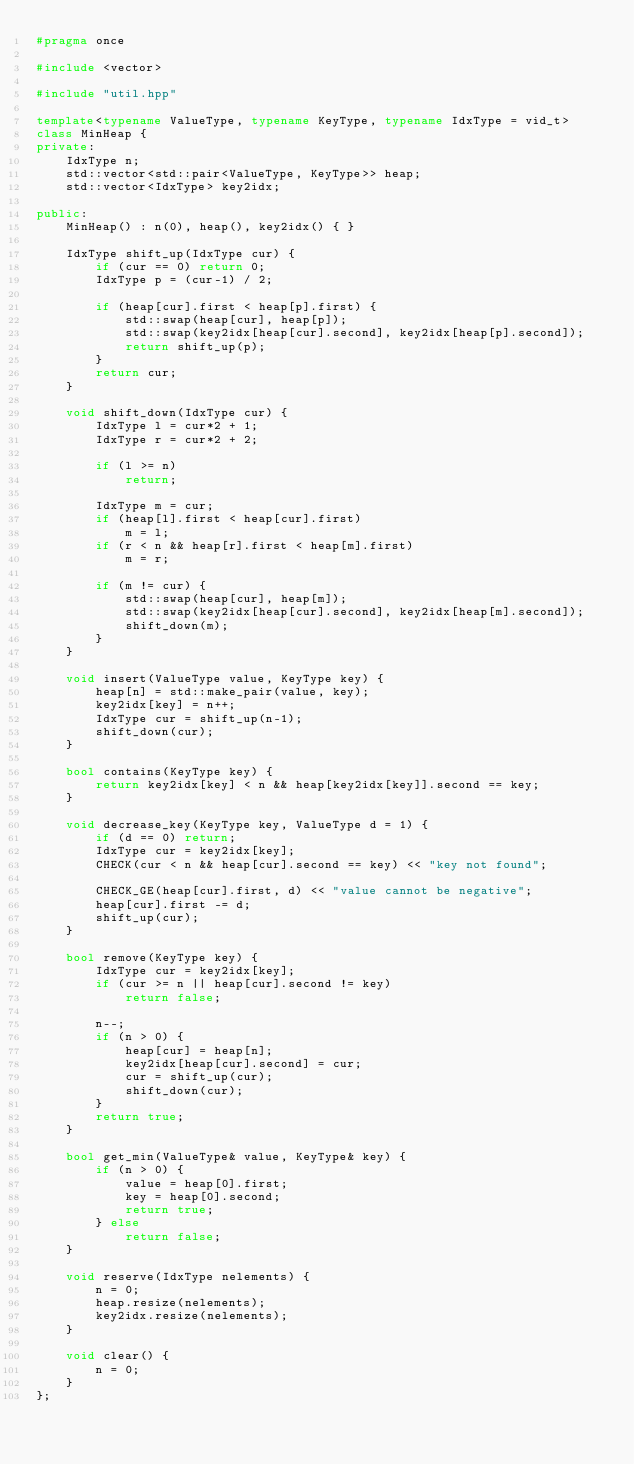<code> <loc_0><loc_0><loc_500><loc_500><_C++_>#pragma once

#include <vector>

#include "util.hpp"

template<typename ValueType, typename KeyType, typename IdxType = vid_t>
class MinHeap {
private:
    IdxType n;
    std::vector<std::pair<ValueType, KeyType>> heap;
    std::vector<IdxType> key2idx;

public:
    MinHeap() : n(0), heap(), key2idx() { }

    IdxType shift_up(IdxType cur) {
        if (cur == 0) return 0;
        IdxType p = (cur-1) / 2;

        if (heap[cur].first < heap[p].first) {
            std::swap(heap[cur], heap[p]);
            std::swap(key2idx[heap[cur].second], key2idx[heap[p].second]);
            return shift_up(p);
        }
        return cur;
    }

    void shift_down(IdxType cur) {
        IdxType l = cur*2 + 1;
        IdxType r = cur*2 + 2;

        if (l >= n)
            return;

        IdxType m = cur;
        if (heap[l].first < heap[cur].first)
            m = l;
        if (r < n && heap[r].first < heap[m].first)
            m = r;

        if (m != cur) {
            std::swap(heap[cur], heap[m]);
            std::swap(key2idx[heap[cur].second], key2idx[heap[m].second]);
            shift_down(m);
        }
    }

    void insert(ValueType value, KeyType key) {
        heap[n] = std::make_pair(value, key);
        key2idx[key] = n++;
        IdxType cur = shift_up(n-1);
        shift_down(cur);
    }

    bool contains(KeyType key) {
        return key2idx[key] < n && heap[key2idx[key]].second == key;
    }

    void decrease_key(KeyType key, ValueType d = 1) {
        if (d == 0) return;
        IdxType cur = key2idx[key];
        CHECK(cur < n && heap[cur].second == key) << "key not found";

        CHECK_GE(heap[cur].first, d) << "value cannot be negative";
        heap[cur].first -= d;
        shift_up(cur);
    }

    bool remove(KeyType key) {
        IdxType cur = key2idx[key];
        if (cur >= n || heap[cur].second != key)
            return false;

        n--;
        if (n > 0) {
            heap[cur] = heap[n];
            key2idx[heap[cur].second] = cur;
            cur = shift_up(cur);
            shift_down(cur);
        }
        return true;
    }

    bool get_min(ValueType& value, KeyType& key) {
        if (n > 0) {
            value = heap[0].first;
            key = heap[0].second;
            return true;
        } else
            return false;
    }

    void reserve(IdxType nelements) {
        n = 0;
        heap.resize(nelements);
        key2idx.resize(nelements);
    }

    void clear() {
        n = 0;
    }
};
</code> 